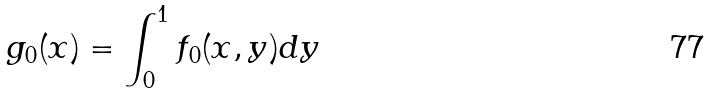<formula> <loc_0><loc_0><loc_500><loc_500>g _ { 0 } ( x ) = \int _ { 0 } ^ { 1 } f _ { 0 } ( x , y ) d y</formula> 